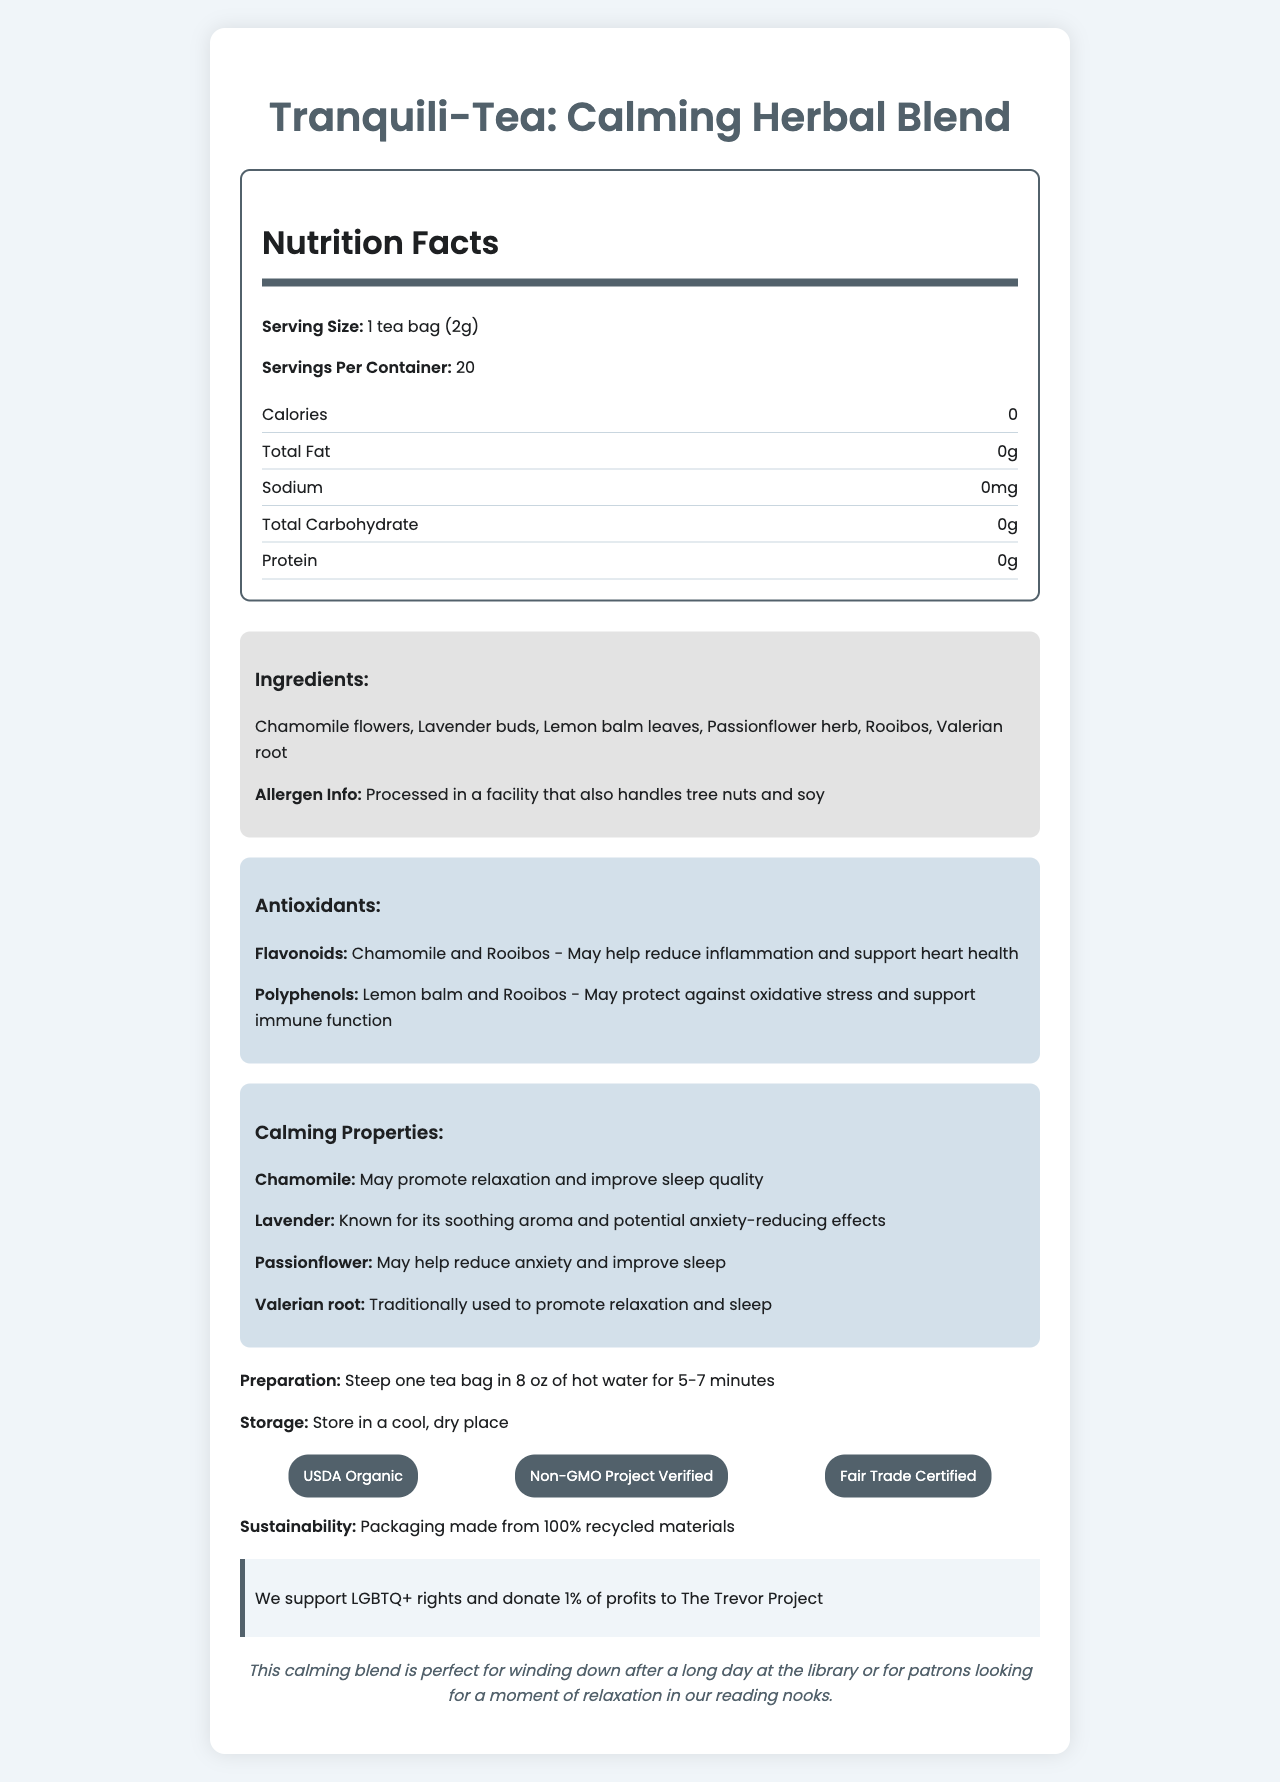what is the product name? The product name is clearly stated at the top of the document as "Tranquili-Tea: Calming Herbal Blend."
Answer: Tranquili-Tea: Calming Herbal Blend how many servings per container are there? The document lists the number of servings per container as 20.
Answer: 20 which ingredients are included in the tea blend? The ingredients are specifically listed in the ingredients section of the document.
Answer: Chamomile flowers, Lavender buds, Lemon balm leaves, Passionflower herb, Rooibos, Valerian root what benefits do the flavonoids provide? The document specifies that flavonoids, sourced from Chamomile and Rooibos, may help reduce inflammation and support heart health.
Answer: May help reduce inflammation and support heart health what certifications does this tea have? The certifications are listed in a dedicated section labeled certifications.
Answer: USDA Organic, Non-GMO Project Verified, Fair Trade Certified which antioxidants are present in the tea blend? A. Carotenoids B. Flavonoids C. Polyphenols D. Vitamin C The document lists Flavonoids and Polyphenols as the antioxidants present in the tea blend.
Answer: B, C what is the serving size for this tea? A. 1 tea bag (1g) B. 1 tea bag (2g) C. 1 tea bag (3g) D. 2 tea bags (4g) The serving size is specified as 1 tea bag (2g).
Answer: B does this tea contain any caffeine? The tea is described as sugar-free and caffeine-free in the product description.
Answer: No what are the company's values? The company values are clearly stated, including support for LGBTQ+ rights and donations to The Trevor Project.
Answer: We support LGBTQ+ rights and donate 1% of profits to The Trevor Project can this tea help with relaxation and improving sleep quality? According to the document, ingredients like Chamomile and Valerian root have benefits that promote relaxation and improve sleep quality.
Answer: Yes how should the tea be prepared? The preparation instructions provided in the document specify this method.
Answer: Steep one tea bag in 8 oz of hot water for 5-7 minutes what is one benefit of consuming polyphenols? The document states that polyphenols may protect against oxidative stress and support immune function.
Answer: May protect against oxidative stress and support immune function is this tea processed in a facility that handles peanuts? The allergen info specifies tree nuts and soy but does not mention peanuts.
Answer: Cannot be determined summarize the main idea of the document. The main idea is an overview of the herbal tea product, emphasizing its calming properties, health benefits, and commitment to sustainability and social values.
Answer: The document provides detailed information about Tranquili-Tea: Calming Herbal Blend, a sugar-free, caffeine-free herbal tea that offers relaxation and antioxidant benefits. It includes nutritional information, ingredients, health benefits, preparation instructions, storage recommendations, certifications, sustainability efforts, and the company's values supporting LGBTQ+ rights. 